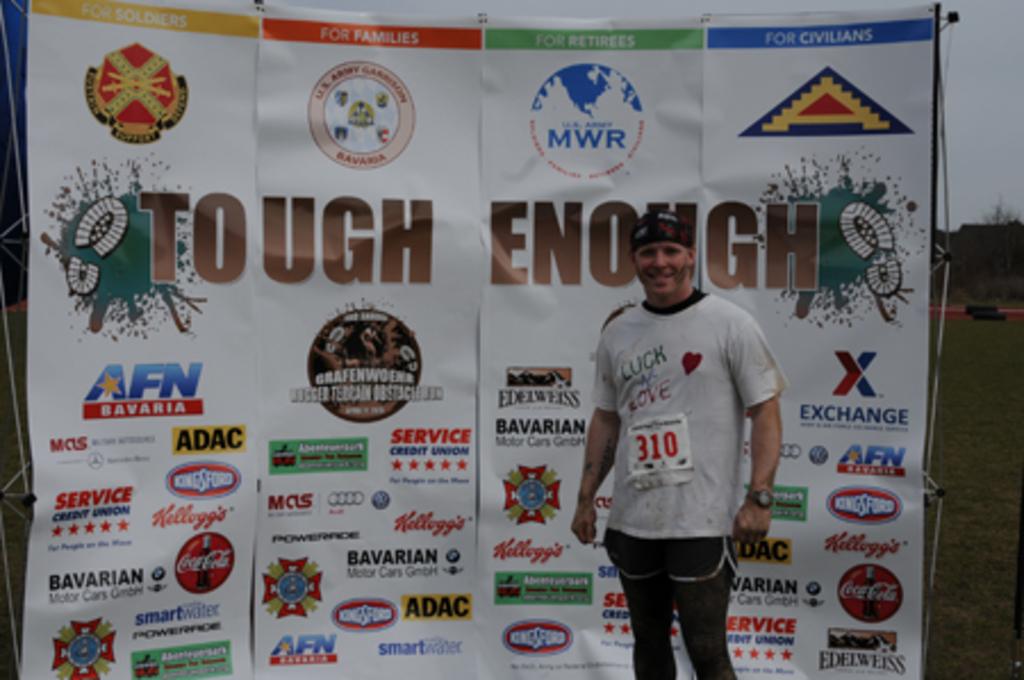What is written in the blue stripe on the top right of the banner?
Provide a succinct answer. For civilians. What is the name of the athletic competition?
Your answer should be very brief. Tough enough. 